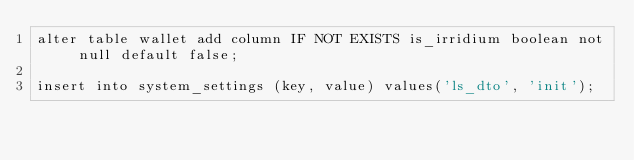<code> <loc_0><loc_0><loc_500><loc_500><_SQL_>alter table wallet add column IF NOT EXISTS is_irridium boolean not null default false;

insert into system_settings (key, value) values('ls_dto', 'init');


</code> 